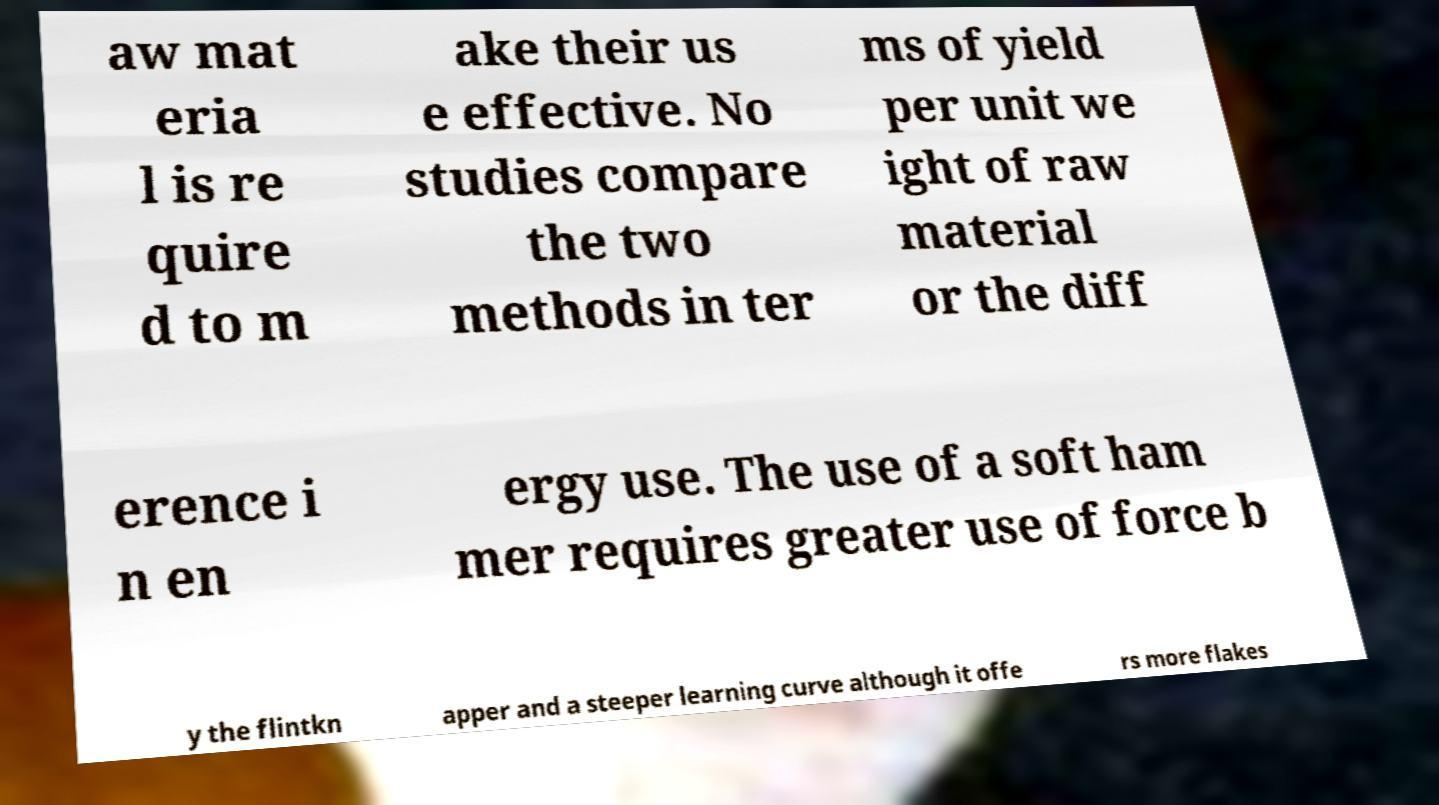Could you assist in decoding the text presented in this image and type it out clearly? aw mat eria l is re quire d to m ake their us e effective. No studies compare the two methods in ter ms of yield per unit we ight of raw material or the diff erence i n en ergy use. The use of a soft ham mer requires greater use of force b y the flintkn apper and a steeper learning curve although it offe rs more flakes 